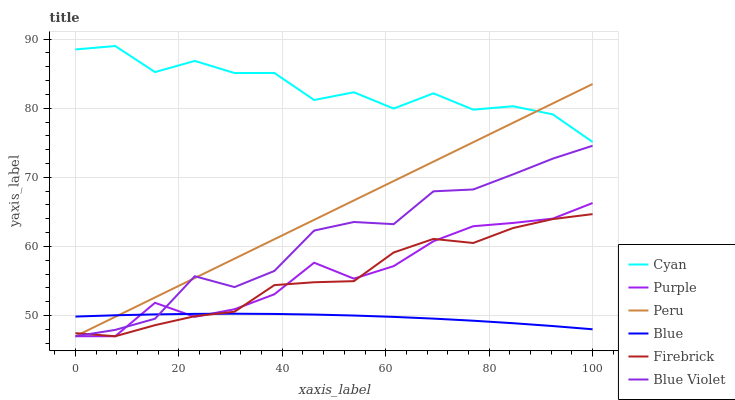Does Blue have the minimum area under the curve?
Answer yes or no. Yes. Does Cyan have the maximum area under the curve?
Answer yes or no. Yes. Does Purple have the minimum area under the curve?
Answer yes or no. No. Does Purple have the maximum area under the curve?
Answer yes or no. No. Is Peru the smoothest?
Answer yes or no. Yes. Is Cyan the roughest?
Answer yes or no. Yes. Is Purple the smoothest?
Answer yes or no. No. Is Purple the roughest?
Answer yes or no. No. Does Purple have the lowest value?
Answer yes or no. Yes. Does Cyan have the lowest value?
Answer yes or no. No. Does Cyan have the highest value?
Answer yes or no. Yes. Does Purple have the highest value?
Answer yes or no. No. Is Blue less than Cyan?
Answer yes or no. Yes. Is Cyan greater than Purple?
Answer yes or no. Yes. Does Purple intersect Blue Violet?
Answer yes or no. Yes. Is Purple less than Blue Violet?
Answer yes or no. No. Is Purple greater than Blue Violet?
Answer yes or no. No. Does Blue intersect Cyan?
Answer yes or no. No. 